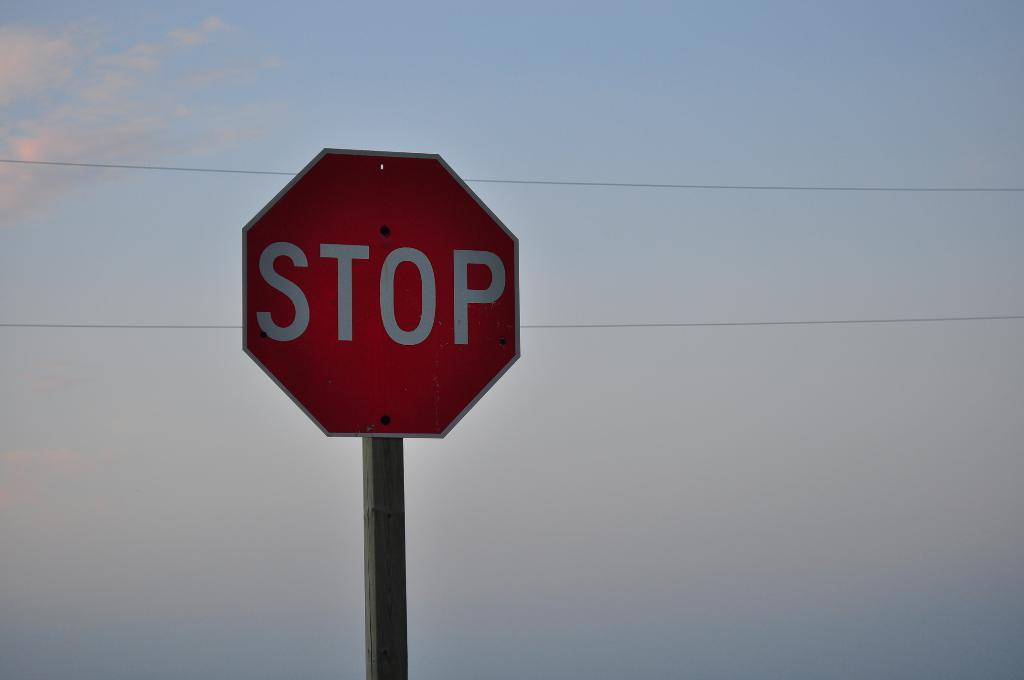Provide a one-sentence caption for the provided image. A STOP sign at sunset in front of a blue sky. 